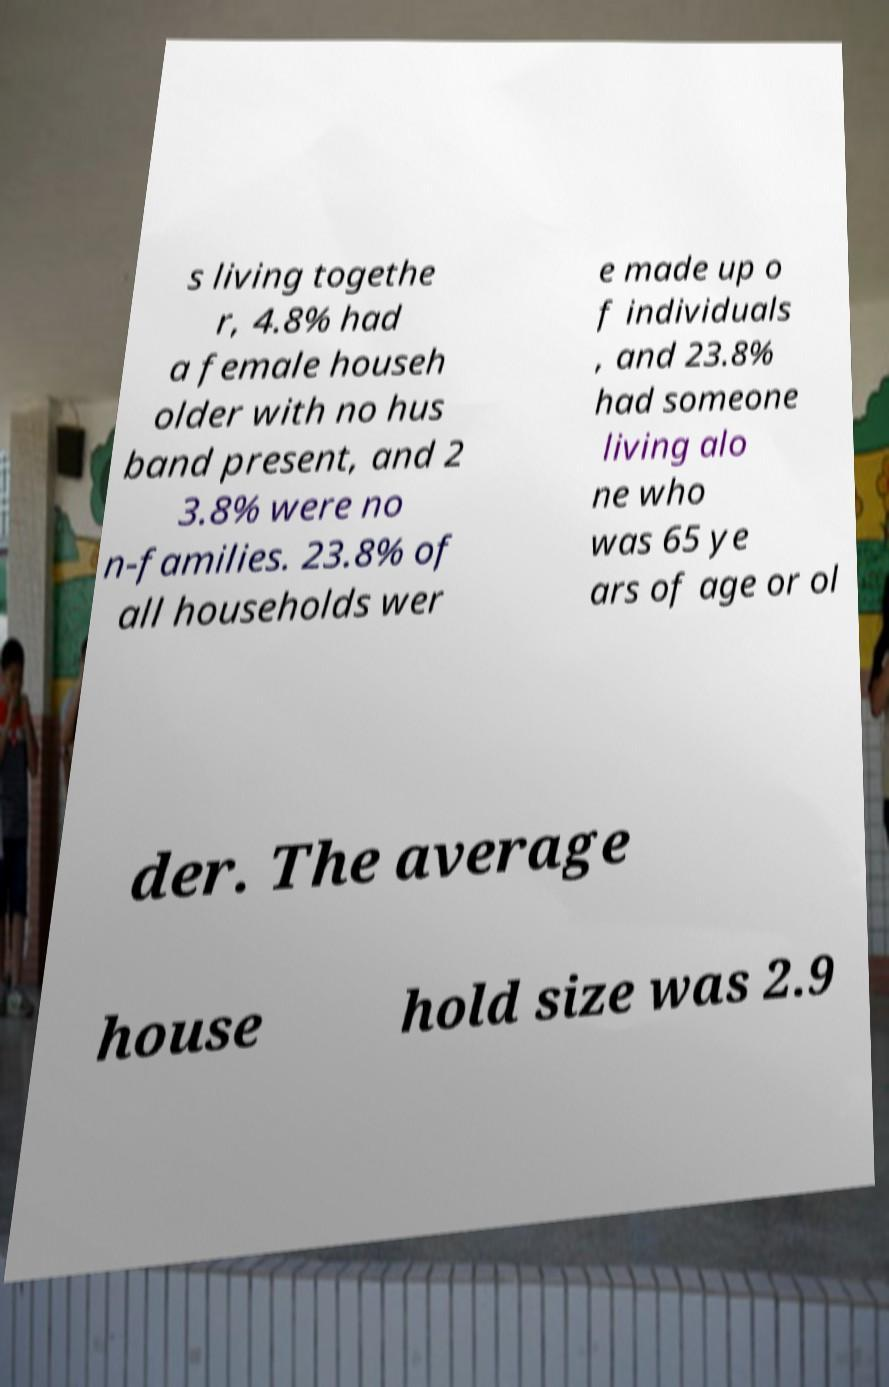I need the written content from this picture converted into text. Can you do that? s living togethe r, 4.8% had a female househ older with no hus band present, and 2 3.8% were no n-families. 23.8% of all households wer e made up o f individuals , and 23.8% had someone living alo ne who was 65 ye ars of age or ol der. The average house hold size was 2.9 